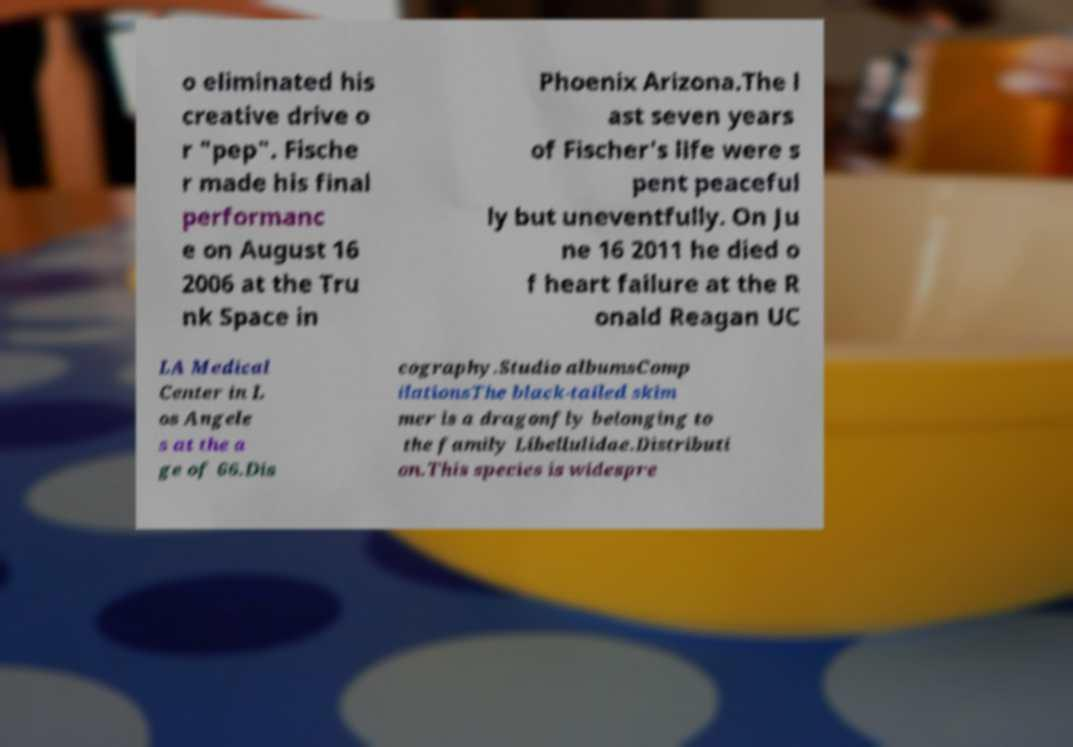Could you assist in decoding the text presented in this image and type it out clearly? o eliminated his creative drive o r "pep". Fische r made his final performanc e on August 16 2006 at the Tru nk Space in Phoenix Arizona.The l ast seven years of Fischer's life were s pent peaceful ly but uneventfully. On Ju ne 16 2011 he died o f heart failure at the R onald Reagan UC LA Medical Center in L os Angele s at the a ge of 66.Dis cography.Studio albumsComp ilationsThe black-tailed skim mer is a dragonfly belonging to the family Libellulidae.Distributi on.This species is widespre 